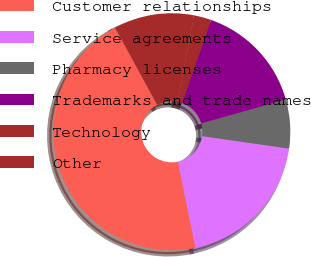Convert chart. <chart><loc_0><loc_0><loc_500><loc_500><pie_chart><fcel>Customer relationships<fcel>Service agreements<fcel>Pharmacy licenses<fcel>Trademarks and trade names<fcel>Technology<fcel>Other<nl><fcel>45.27%<fcel>19.53%<fcel>6.65%<fcel>15.24%<fcel>2.36%<fcel>10.95%<nl></chart> 